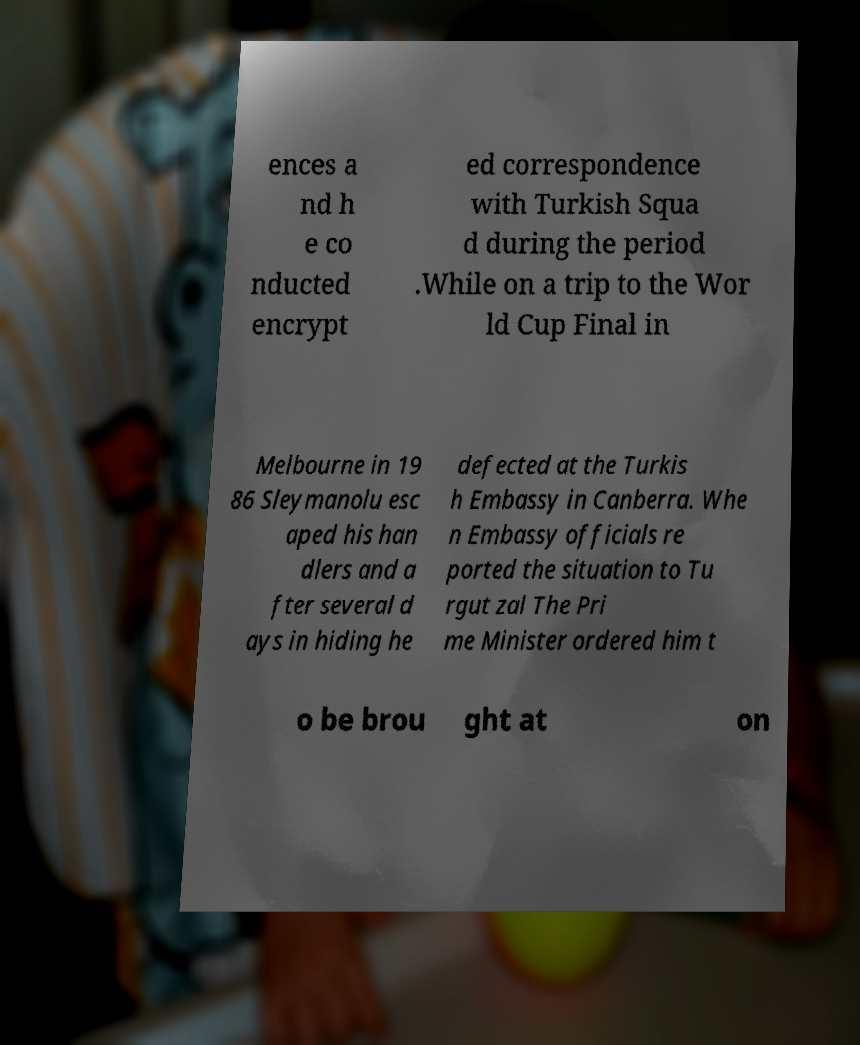Can you accurately transcribe the text from the provided image for me? ences a nd h e co nducted encrypt ed correspondence with Turkish Squa d during the period .While on a trip to the Wor ld Cup Final in Melbourne in 19 86 Sleymanolu esc aped his han dlers and a fter several d ays in hiding he defected at the Turkis h Embassy in Canberra. Whe n Embassy officials re ported the situation to Tu rgut zal The Pri me Minister ordered him t o be brou ght at on 